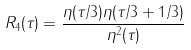Convert formula to latex. <formula><loc_0><loc_0><loc_500><loc_500>R _ { 4 } ( \tau ) = \frac { \eta ( \tau / 3 ) \eta ( \tau / 3 + 1 / 3 ) } { \eta ^ { 2 } ( \tau ) }</formula> 